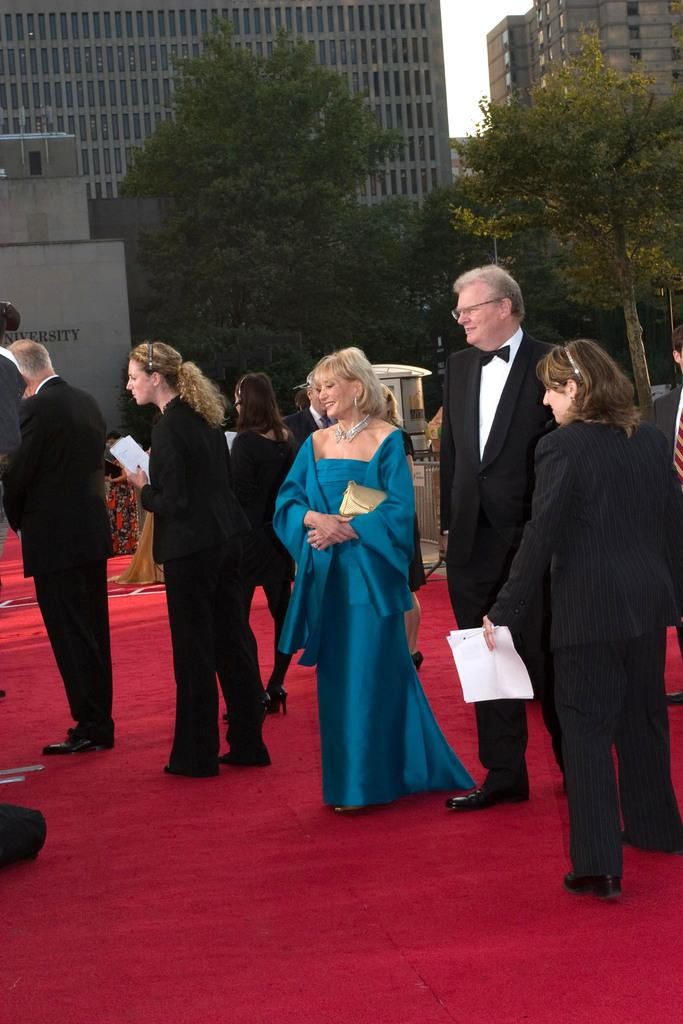How many people are in the image? There is a group of people in the image, but the exact number cannot be determined from the provided facts. What is the surface the people are standing on? The people are standing on a red carpet. What can be seen in the background of the image? There are trees, iron grills, buildings, and the sky visible in the background of the image. What sign is the person holding in the image? There is no sign visible in the image; the people are simply standing on a red carpet. What caption would you give to the image? It is not possible to provide a caption for the image based on the provided facts, as they do not offer any context or information about the purpose or meaning of the scene. 